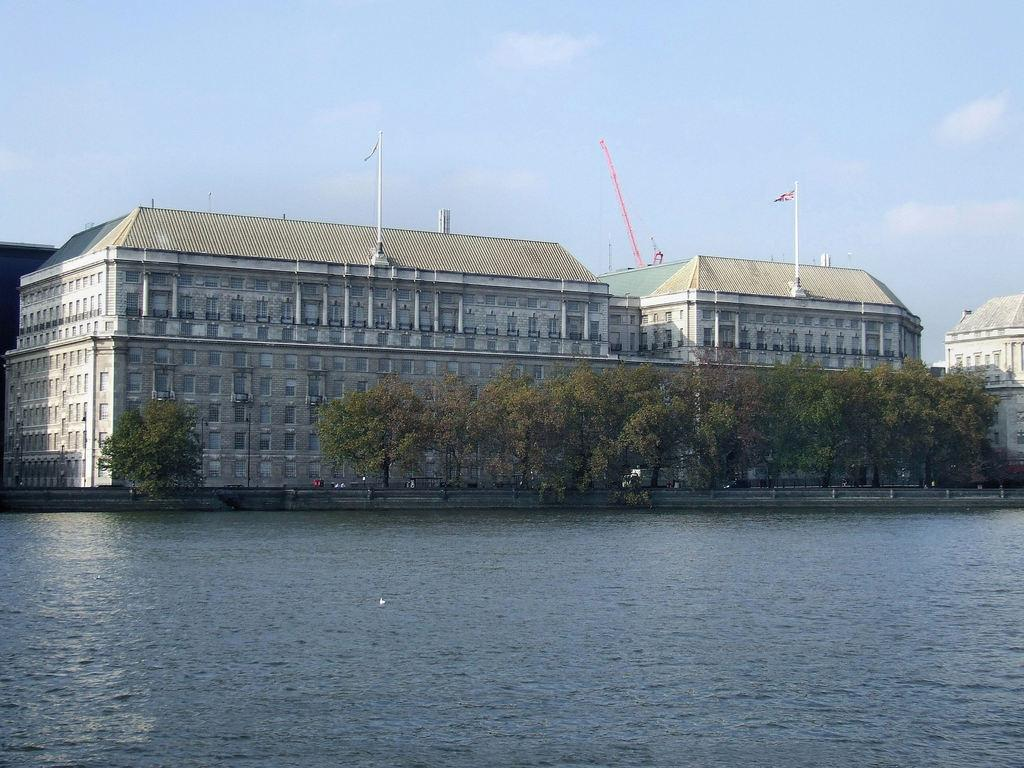What type of natural feature is at the bottom of the image? There is a river at the bottom of the image. What structures can be seen in the background of the image? There are buildings and poles in the background of the image. What type of vegetation is present in the background of the image? There are trees in the background of the image. What is visible at the top of the image? The sky is visible at the top of the image. How many grandmothers are present in the image? There is no grandmother present in the image. What type of service do the servants provide in the image? There are no servants present in the image. 